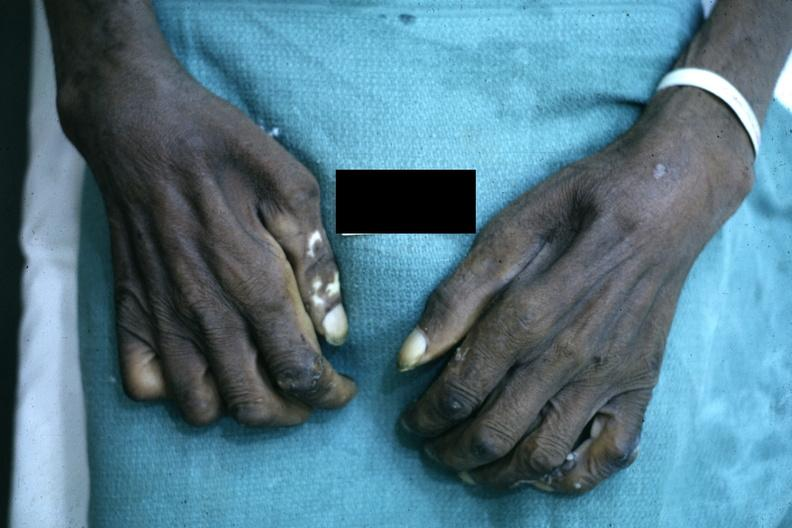what are present?
Answer the question using a single word or phrase. Extremities 